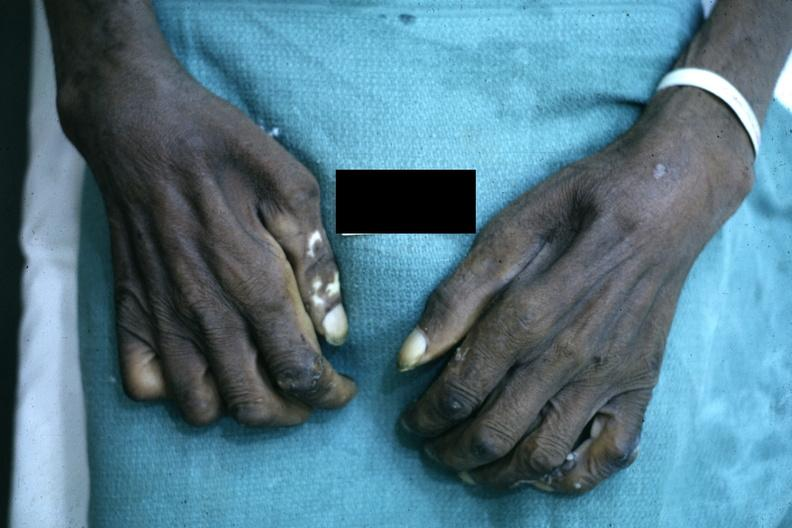what are present?
Answer the question using a single word or phrase. Extremities 